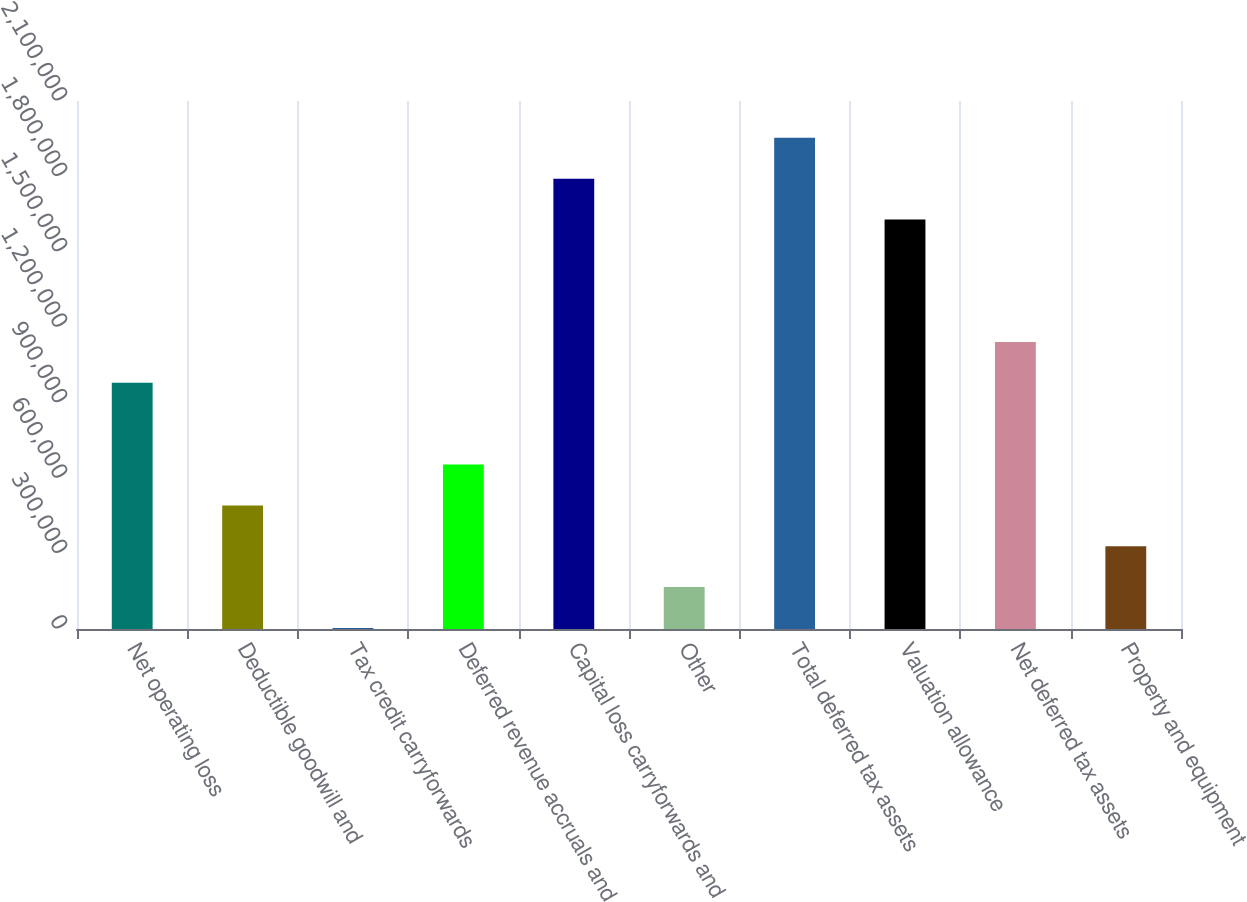<chart> <loc_0><loc_0><loc_500><loc_500><bar_chart><fcel>Net operating loss<fcel>Deductible goodwill and<fcel>Tax credit carryforwards<fcel>Deferred revenue accruals and<fcel>Capital loss carryforwards and<fcel>Other<fcel>Total deferred tax assets<fcel>Valuation allowance<fcel>Net deferred tax assets<fcel>Property and equipment<nl><fcel>978917<fcel>491674<fcel>4432<fcel>654088<fcel>1.79099e+06<fcel>166846<fcel>1.9534e+06<fcel>1.62857e+06<fcel>1.14133e+06<fcel>329260<nl></chart> 